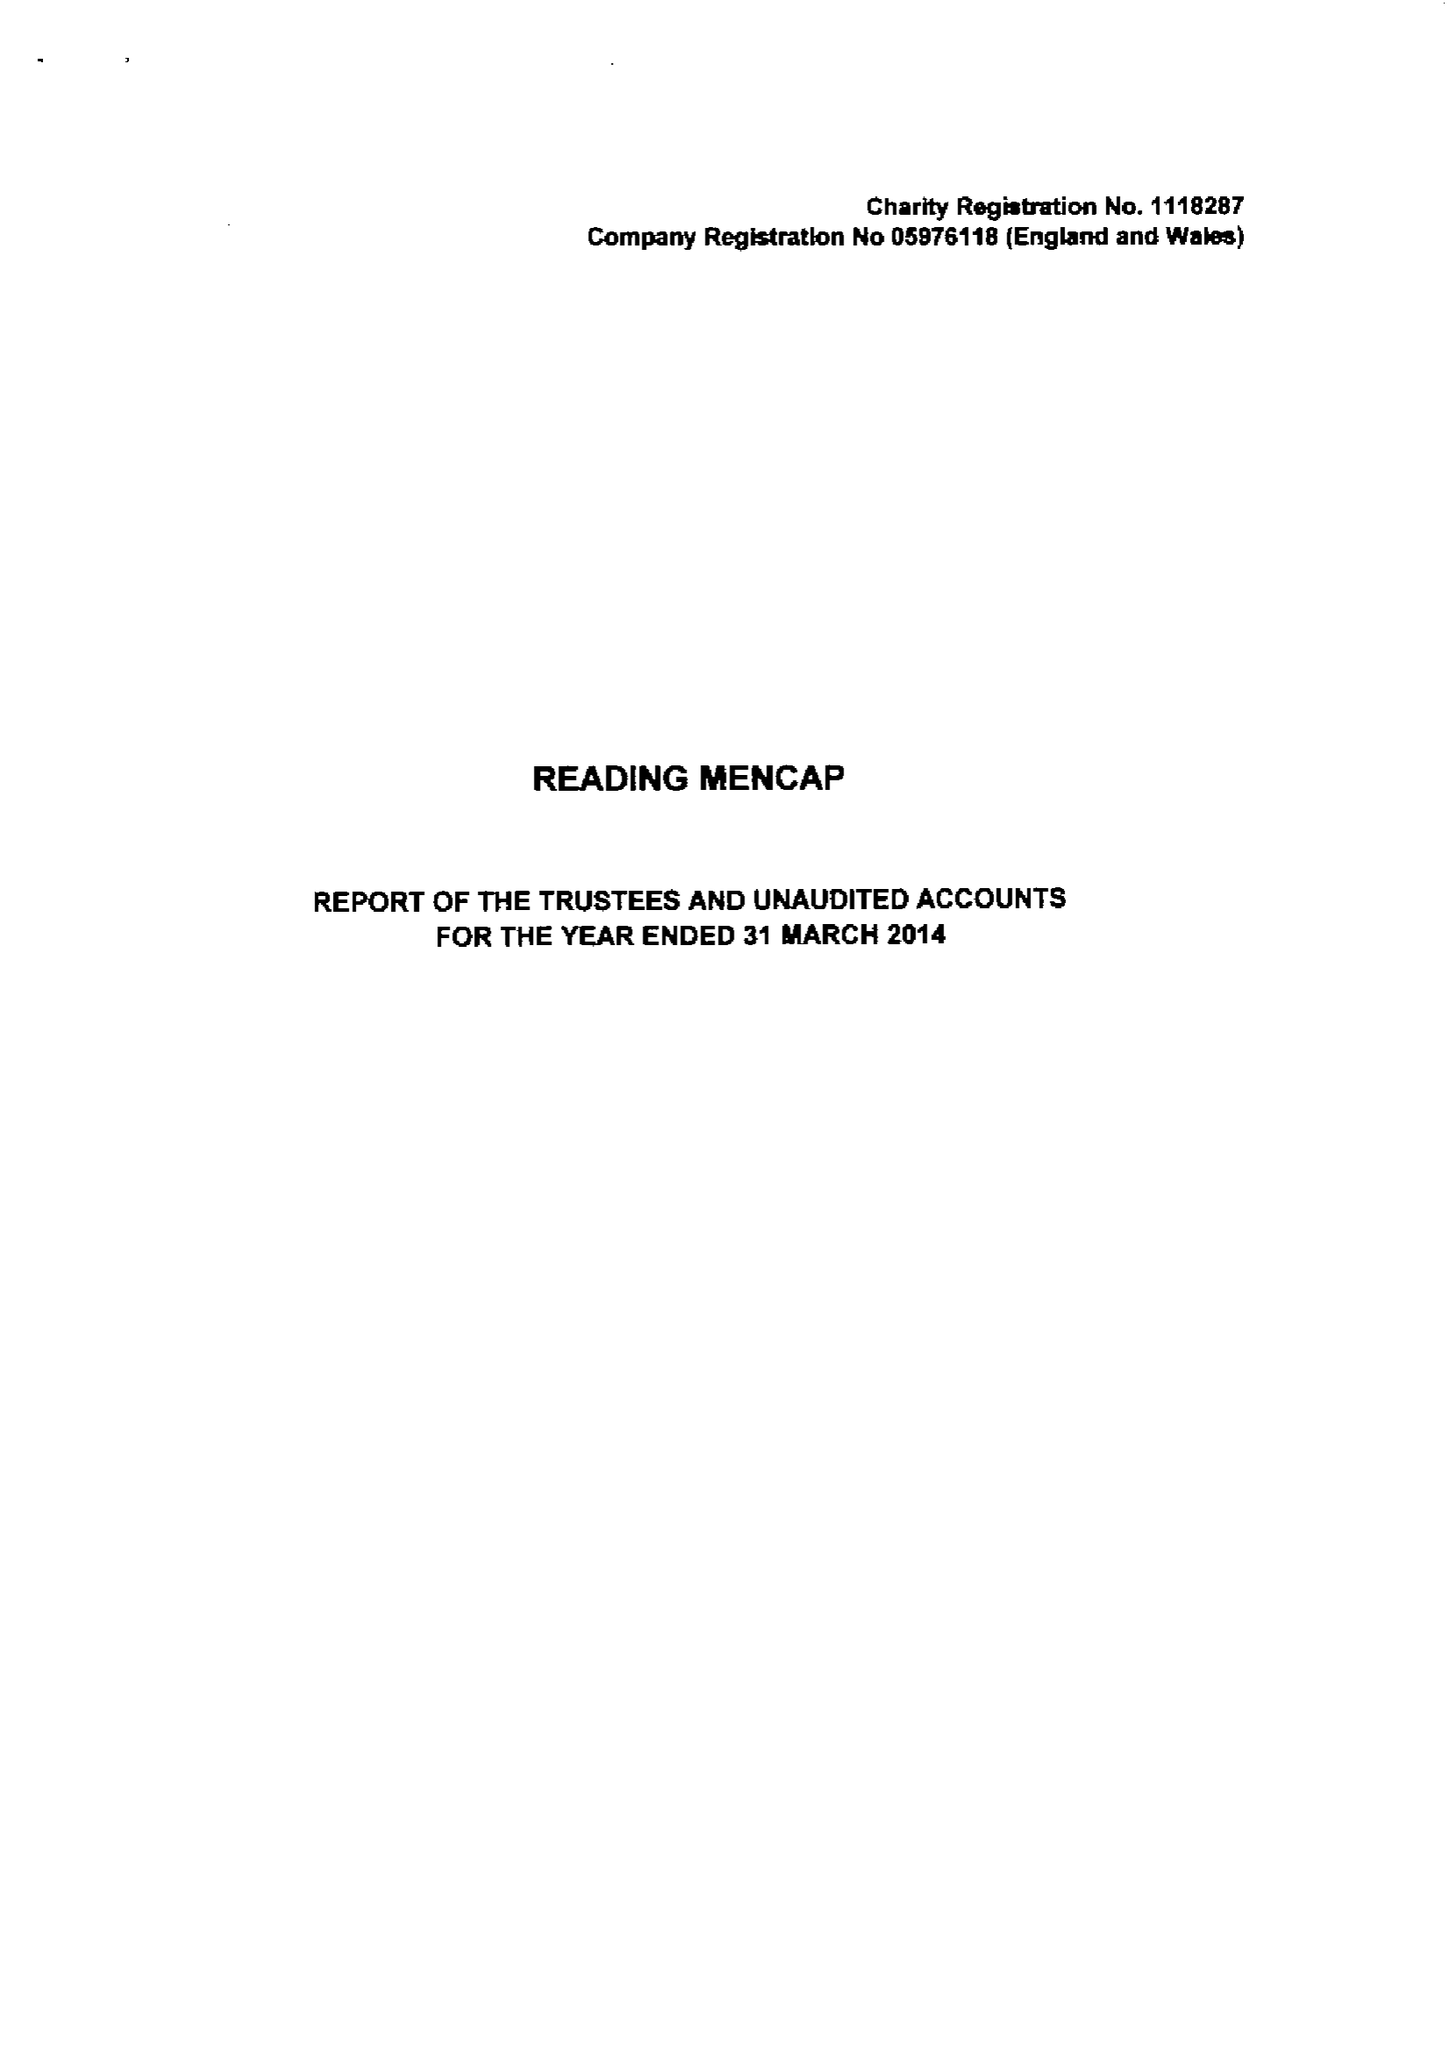What is the value for the address__street_line?
Answer the question using a single word or phrase. 21 ALEXANDRA ROAD 